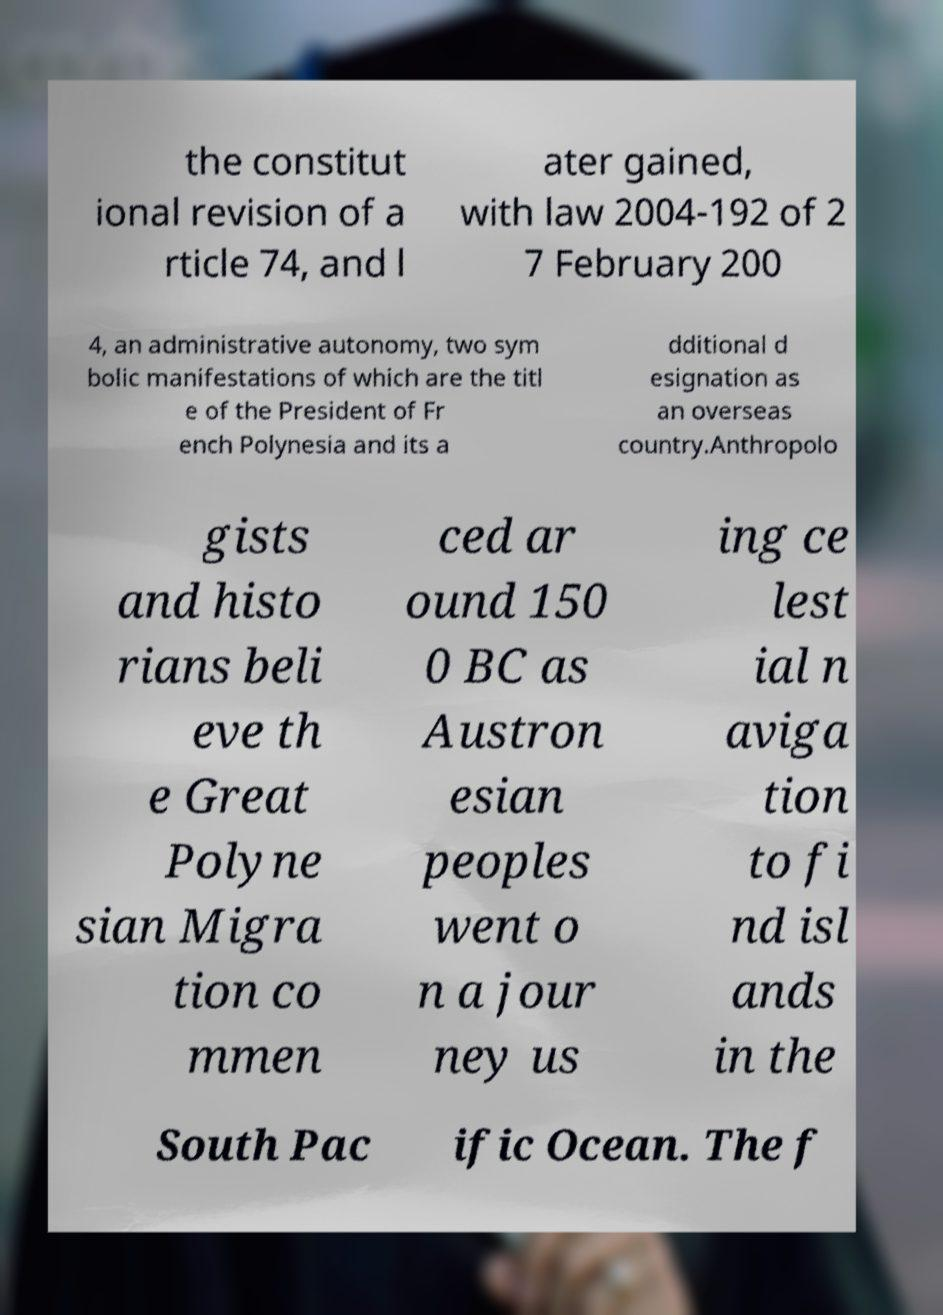Please read and relay the text visible in this image. What does it say? the constitut ional revision of a rticle 74, and l ater gained, with law 2004-192 of 2 7 February 200 4, an administrative autonomy, two sym bolic manifestations of which are the titl e of the President of Fr ench Polynesia and its a dditional d esignation as an overseas country.Anthropolo gists and histo rians beli eve th e Great Polyne sian Migra tion co mmen ced ar ound 150 0 BC as Austron esian peoples went o n a jour ney us ing ce lest ial n aviga tion to fi nd isl ands in the South Pac ific Ocean. The f 